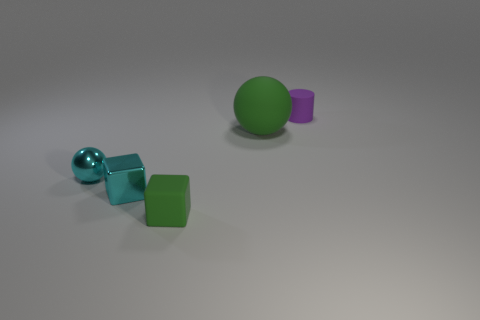What number of things are either tiny cubes or small things that are left of the cylinder?
Keep it short and to the point. 3. There is a metallic block that is the same color as the shiny sphere; what size is it?
Your response must be concise. Small. There is a green object on the left side of the big green object; what is its shape?
Provide a succinct answer. Cube. Does the tiny cylinder that is behind the large sphere have the same color as the small metal sphere?
Make the answer very short. No. There is a tiny cube that is the same color as the big sphere; what material is it?
Your response must be concise. Rubber. There is a green thing behind the cyan shiny sphere; is its size the same as the small green thing?
Your answer should be very brief. No. Are there any small matte cylinders that have the same color as the shiny block?
Offer a very short reply. No. There is a object that is left of the cyan metallic cube; are there any tiny cyan balls that are behind it?
Provide a short and direct response. No. Is there a yellow ball made of the same material as the tiny purple cylinder?
Give a very brief answer. No. There is a sphere that is on the right side of the tiny thing that is to the left of the cyan shiny block; what is it made of?
Provide a succinct answer. Rubber. 